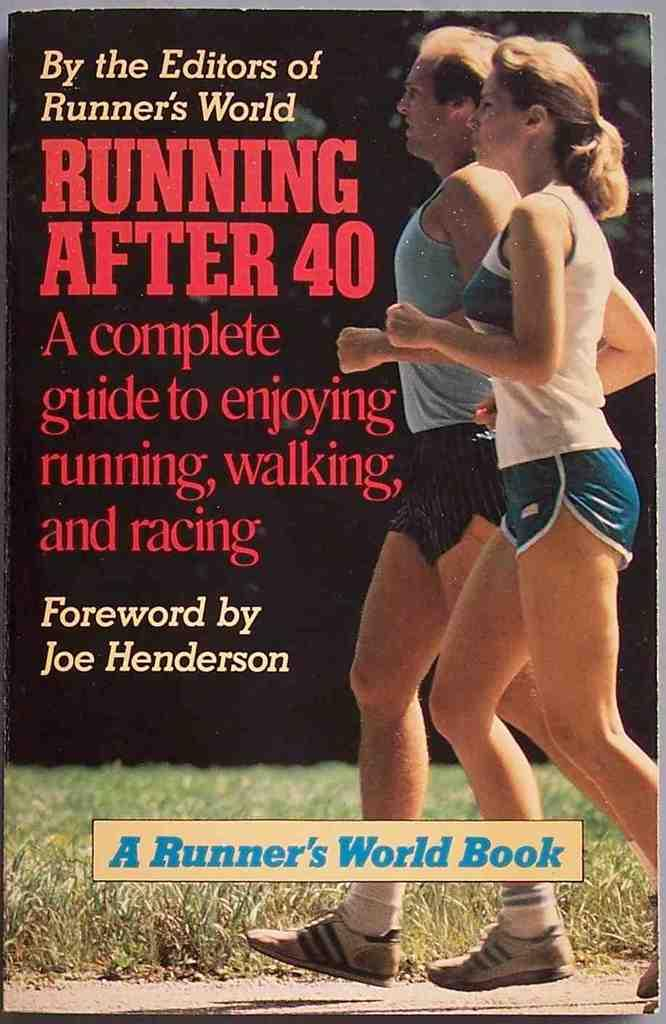<image>
Relay a brief, clear account of the picture shown. the number 40 that is on a cover 